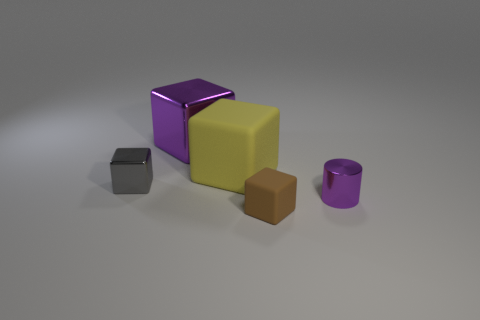How would you describe the overall arrangement of objects in this image? The objects are arranged neatly with adequate space between them, on a flat surface. From left to right, there is a small grey cube, a larger reflective purple cube, a big yellow matte cube, a brown matte cube, and a reflective purple cylinder. Does the lighting in the image suggest a particular time of day or type of light source? The uniform and diffused lighting in the image suggests an artificial light source, likely within a controlled environment like a studio rather than natural daylight. 